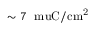<formula> <loc_0><loc_0><loc_500><loc_500>\sim 7 \ m u C / c m ^ { 2 }</formula> 